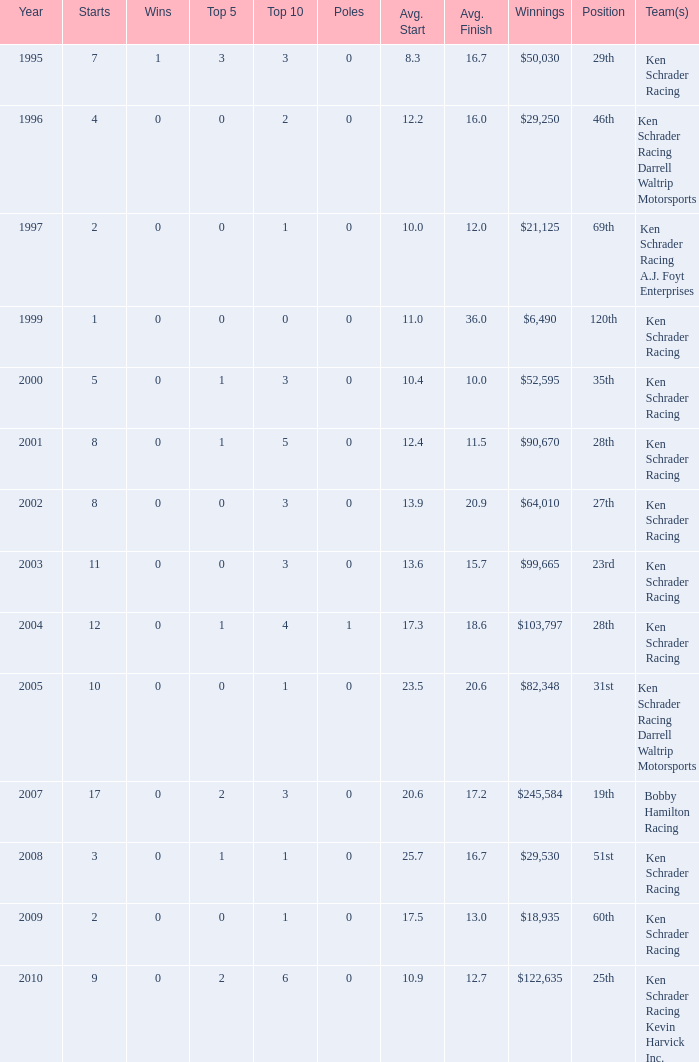7? 0.0. 